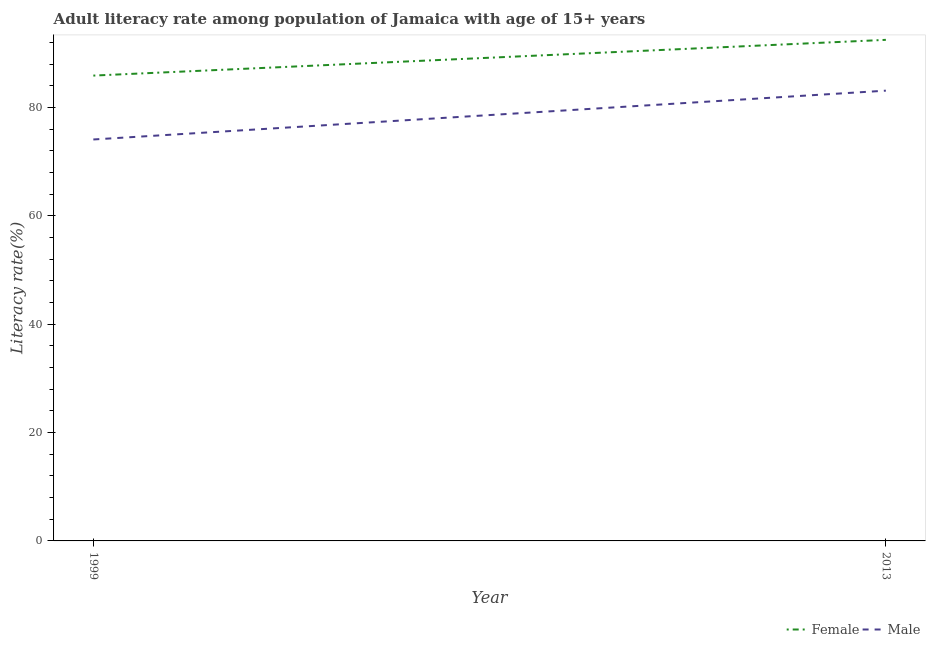How many different coloured lines are there?
Make the answer very short. 2. Does the line corresponding to female adult literacy rate intersect with the line corresponding to male adult literacy rate?
Your answer should be very brief. No. Is the number of lines equal to the number of legend labels?
Ensure brevity in your answer.  Yes. What is the female adult literacy rate in 2013?
Give a very brief answer. 92.47. Across all years, what is the maximum female adult literacy rate?
Your answer should be compact. 92.47. Across all years, what is the minimum female adult literacy rate?
Offer a very short reply. 85.87. In which year was the male adult literacy rate minimum?
Keep it short and to the point. 1999. What is the total male adult literacy rate in the graph?
Your answer should be compact. 157.17. What is the difference between the female adult literacy rate in 1999 and that in 2013?
Ensure brevity in your answer.  -6.6. What is the difference between the male adult literacy rate in 2013 and the female adult literacy rate in 1999?
Give a very brief answer. -2.78. What is the average female adult literacy rate per year?
Give a very brief answer. 89.17. In the year 1999, what is the difference between the female adult literacy rate and male adult literacy rate?
Your answer should be very brief. 11.79. In how many years, is the female adult literacy rate greater than 8 %?
Your answer should be compact. 2. What is the ratio of the female adult literacy rate in 1999 to that in 2013?
Ensure brevity in your answer.  0.93. Is the female adult literacy rate in 1999 less than that in 2013?
Your answer should be very brief. Yes. In how many years, is the male adult literacy rate greater than the average male adult literacy rate taken over all years?
Keep it short and to the point. 1. Does the female adult literacy rate monotonically increase over the years?
Your response must be concise. Yes. Is the male adult literacy rate strictly greater than the female adult literacy rate over the years?
Make the answer very short. No. How many lines are there?
Give a very brief answer. 2. How many years are there in the graph?
Provide a succinct answer. 2. What is the difference between two consecutive major ticks on the Y-axis?
Give a very brief answer. 20. Where does the legend appear in the graph?
Make the answer very short. Bottom right. How many legend labels are there?
Offer a very short reply. 2. What is the title of the graph?
Give a very brief answer. Adult literacy rate among population of Jamaica with age of 15+ years. What is the label or title of the X-axis?
Ensure brevity in your answer.  Year. What is the label or title of the Y-axis?
Your response must be concise. Literacy rate(%). What is the Literacy rate(%) of Female in 1999?
Your answer should be very brief. 85.87. What is the Literacy rate(%) of Male in 1999?
Make the answer very short. 74.08. What is the Literacy rate(%) in Female in 2013?
Your answer should be very brief. 92.47. What is the Literacy rate(%) in Male in 2013?
Keep it short and to the point. 83.09. Across all years, what is the maximum Literacy rate(%) in Female?
Provide a short and direct response. 92.47. Across all years, what is the maximum Literacy rate(%) in Male?
Give a very brief answer. 83.09. Across all years, what is the minimum Literacy rate(%) of Female?
Provide a succinct answer. 85.87. Across all years, what is the minimum Literacy rate(%) in Male?
Your answer should be very brief. 74.08. What is the total Literacy rate(%) of Female in the graph?
Your answer should be very brief. 178.34. What is the total Literacy rate(%) of Male in the graph?
Keep it short and to the point. 157.17. What is the difference between the Literacy rate(%) of Female in 1999 and that in 2013?
Your response must be concise. -6.6. What is the difference between the Literacy rate(%) of Male in 1999 and that in 2013?
Provide a short and direct response. -9.01. What is the difference between the Literacy rate(%) of Female in 1999 and the Literacy rate(%) of Male in 2013?
Your response must be concise. 2.78. What is the average Literacy rate(%) of Female per year?
Keep it short and to the point. 89.17. What is the average Literacy rate(%) of Male per year?
Give a very brief answer. 78.59. In the year 1999, what is the difference between the Literacy rate(%) of Female and Literacy rate(%) of Male?
Offer a terse response. 11.79. In the year 2013, what is the difference between the Literacy rate(%) of Female and Literacy rate(%) of Male?
Your response must be concise. 9.37. What is the ratio of the Literacy rate(%) in Female in 1999 to that in 2013?
Keep it short and to the point. 0.93. What is the ratio of the Literacy rate(%) of Male in 1999 to that in 2013?
Keep it short and to the point. 0.89. What is the difference between the highest and the second highest Literacy rate(%) of Female?
Your response must be concise. 6.6. What is the difference between the highest and the second highest Literacy rate(%) of Male?
Offer a terse response. 9.01. What is the difference between the highest and the lowest Literacy rate(%) in Female?
Your answer should be very brief. 6.6. What is the difference between the highest and the lowest Literacy rate(%) in Male?
Provide a succinct answer. 9.01. 